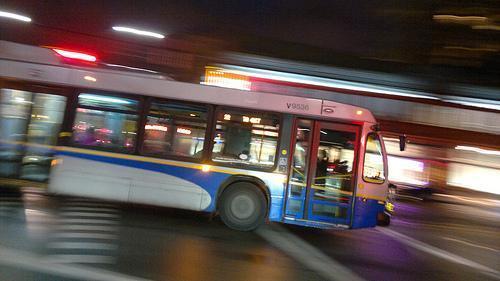How many buses are there?
Give a very brief answer. 1. 